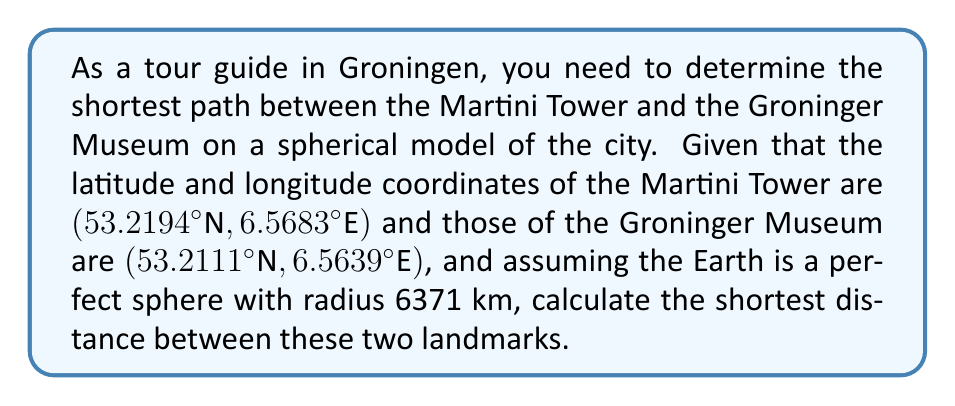Could you help me with this problem? To solve this problem, we'll use the great circle distance formula, which gives the shortest path between two points on a sphere. The steps are as follows:

1) Convert the coordinates from degrees to radians:
   Martini Tower: $\phi_1 = 53.2194° \times \frac{\pi}{180} = 0.9287$ rad
                  $\lambda_1 = 6.5683° \times \frac{\pi}{180} = 0.1146$ rad
   Groninger Museum: $\phi_2 = 53.2111° \times \frac{\pi}{180} = 0.9286$ rad
                     $\lambda_2 = 6.5639° \times \frac{\pi}{180} = 0.1145$ rad

2) Apply the Haversine formula:
   $$a = \sin^2(\frac{\phi_2 - \phi_1}{2}) + \cos(\phi_1)\cos(\phi_2)\sin^2(\frac{\lambda_2 - \lambda_1}{2})$$

3) Calculate the central angle:
   $$c = 2 \times \arctan2(\sqrt{a}, \sqrt{1-a})$$

4) Calculate the distance:
   $$d = R \times c$$
   where $R$ is the radius of the Earth (6371 km)

5) Plugging in the values:
   $$a = \sin^2(\frac{0.9286 - 0.9287}{2}) + \cos(0.9287)\cos(0.9286)\sin^2(\frac{0.1145 - 0.1146}{2})$$
   $$a = 1.2345 \times 10^{-8}$$

   $$c = 2 \times \arctan2(\sqrt{1.2345 \times 10^{-8}}, \sqrt{1 - 1.2345 \times 10^{-8}})$$
   $$c = 1.5712 \times 10^{-4}$$

   $$d = 6371 \times 1.5712 \times 10^{-4} = 1.0010 \text{ km}$$
Answer: 1.0010 km 